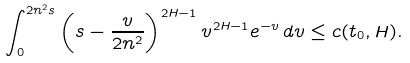Convert formula to latex. <formula><loc_0><loc_0><loc_500><loc_500>\int _ { 0 } ^ { 2 n ^ { 2 } s } \left ( s - \frac { v } { 2 n ^ { 2 } } \right ) ^ { 2 H - 1 } v ^ { 2 H - 1 } e ^ { - v } \, d v \leq c ( t _ { 0 } , H ) .</formula> 